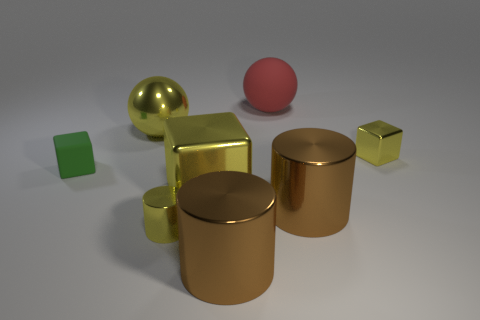Subtract all tiny yellow shiny cubes. How many cubes are left? 2 Add 2 matte objects. How many objects exist? 10 Subtract 1 cubes. How many cubes are left? 2 Subtract all blocks. How many objects are left? 5 Subtract all yellow cylinders. How many cylinders are left? 2 Subtract all brown spheres. How many blue blocks are left? 0 Subtract all big brown shiny things. Subtract all cubes. How many objects are left? 3 Add 2 yellow metallic cubes. How many yellow metallic cubes are left? 4 Add 7 big brown things. How many big brown things exist? 9 Subtract 2 brown cylinders. How many objects are left? 6 